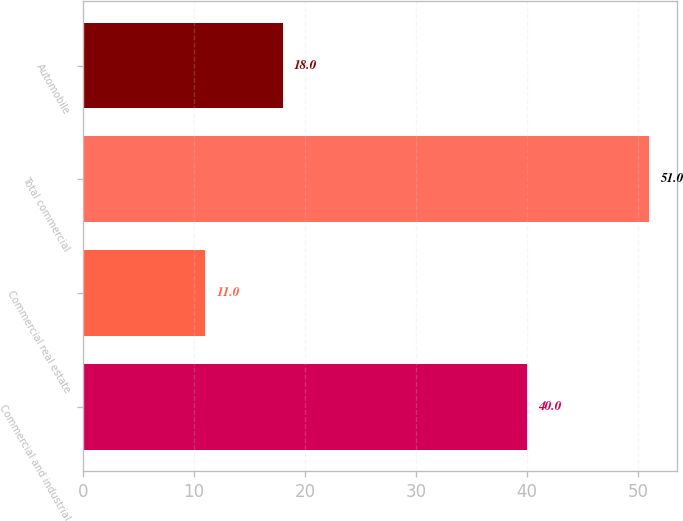<chart> <loc_0><loc_0><loc_500><loc_500><bar_chart><fcel>Commercial and industrial<fcel>Commercial real estate<fcel>Total commercial<fcel>Automobile<nl><fcel>40<fcel>11<fcel>51<fcel>18<nl></chart> 